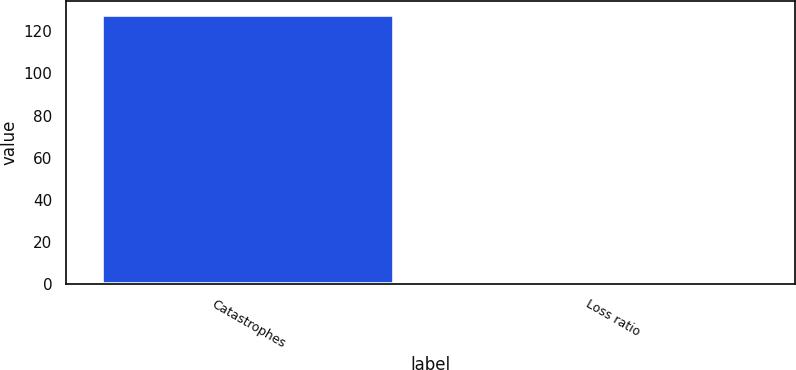<chart> <loc_0><loc_0><loc_500><loc_500><bar_chart><fcel>Catastrophes<fcel>Loss ratio<nl><fcel>127.9<fcel>0.5<nl></chart> 